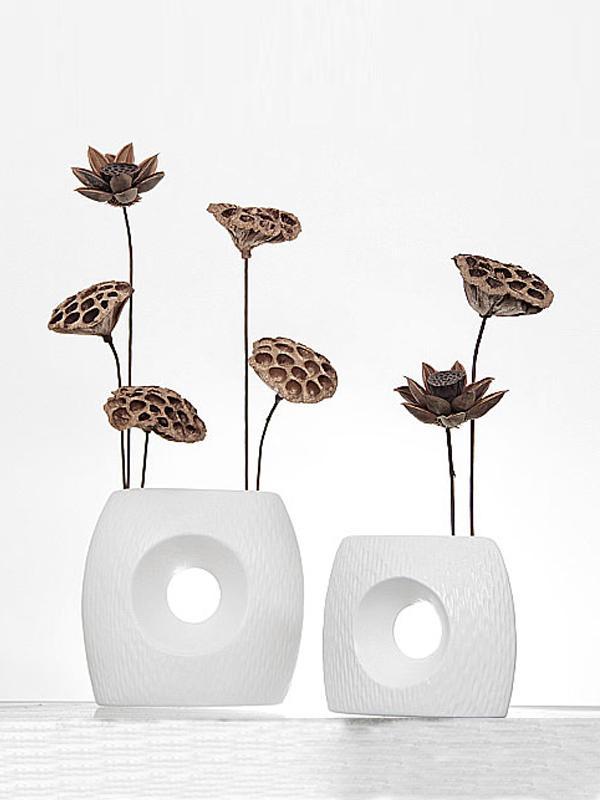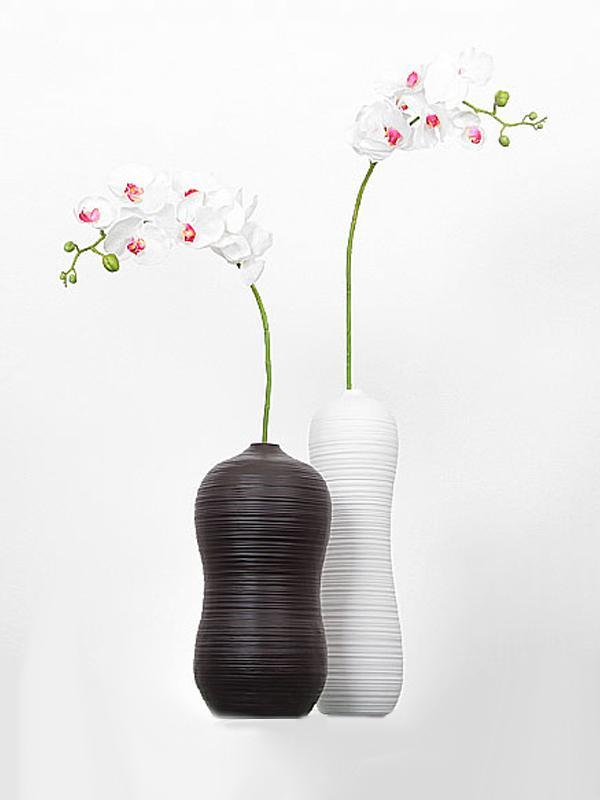The first image is the image on the left, the second image is the image on the right. Considering the images on both sides, is "In one of the image there is a black vase with a flower sticking out." valid? Answer yes or no. Yes. The first image is the image on the left, the second image is the image on the right. Assess this claim about the two images: "One vase is the exact size and shape as another one of the vases.". Correct or not? Answer yes or no. No. 